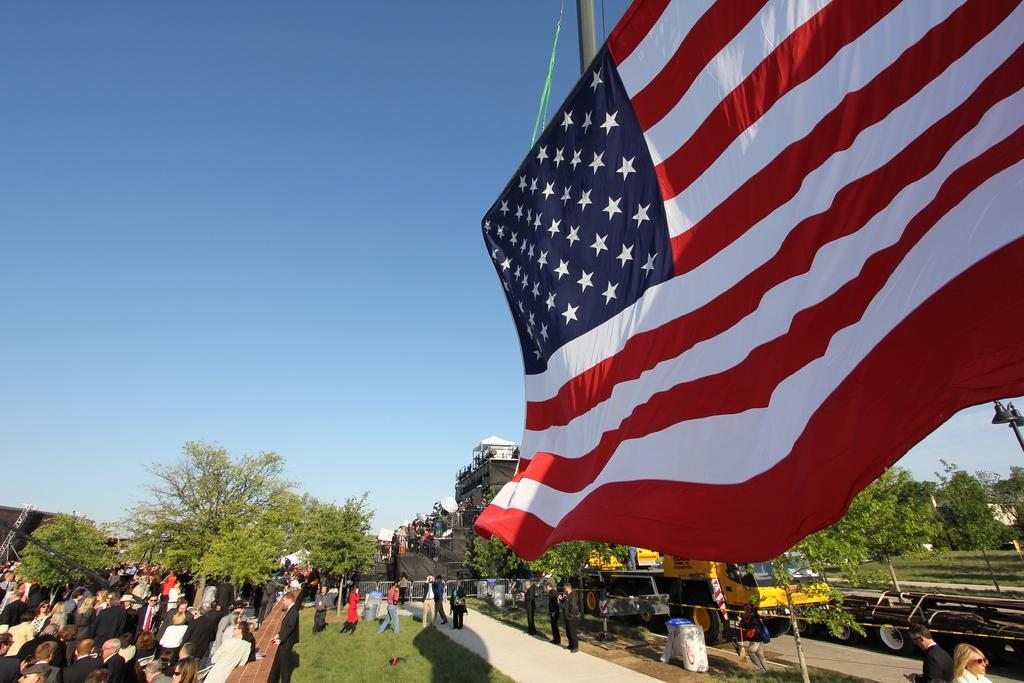What is located at the bottom of the image? There is a crowd at the bottom of the image. What else can be seen on the ground in the image? Vehicles are present on the ground. What is visible in the background of the image? Trees, buildings, and a flag are visible in the background of the image. What is the condition of the sky in the image? The sky is visible at the top of the image, and it appears to have been taken during the day. What is the name of the lawyer standing next to the flag in the image? There is no lawyer present in the image, and no names are mentioned. How does the flag move in the image? The flag does not move in the image; it is stationary. 